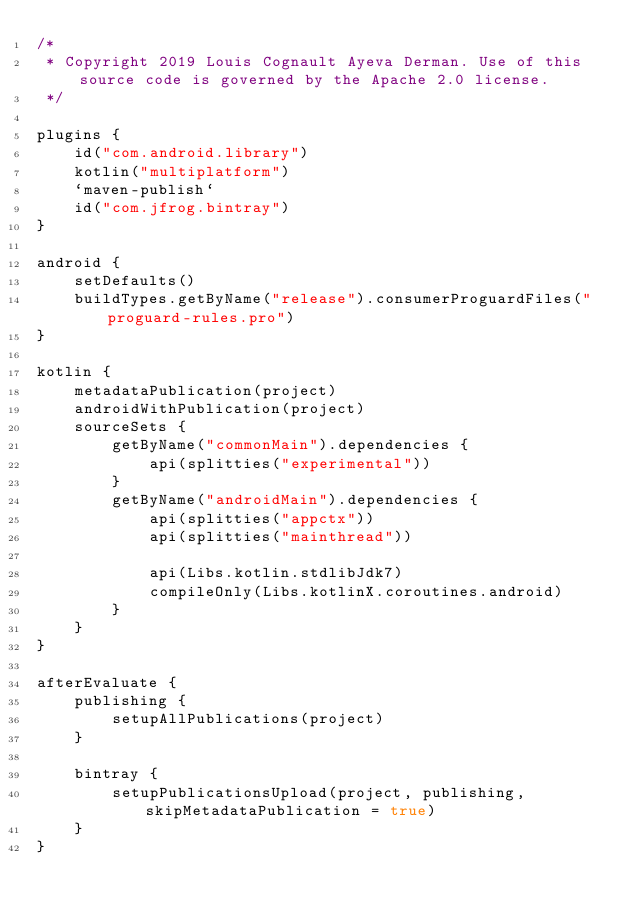Convert code to text. <code><loc_0><loc_0><loc_500><loc_500><_Kotlin_>/*
 * Copyright 2019 Louis Cognault Ayeva Derman. Use of this source code is governed by the Apache 2.0 license.
 */

plugins {
    id("com.android.library")
    kotlin("multiplatform")
    `maven-publish`
    id("com.jfrog.bintray")
}

android {
    setDefaults()
    buildTypes.getByName("release").consumerProguardFiles("proguard-rules.pro")
}

kotlin {
    metadataPublication(project)
    androidWithPublication(project)
    sourceSets {
        getByName("commonMain").dependencies {
            api(splitties("experimental"))
        }
        getByName("androidMain").dependencies {
            api(splitties("appctx"))
            api(splitties("mainthread"))

            api(Libs.kotlin.stdlibJdk7)
            compileOnly(Libs.kotlinX.coroutines.android)
        }
    }
}

afterEvaluate {
    publishing {
        setupAllPublications(project)
    }

    bintray {
        setupPublicationsUpload(project, publishing, skipMetadataPublication = true)
    }
}
</code> 